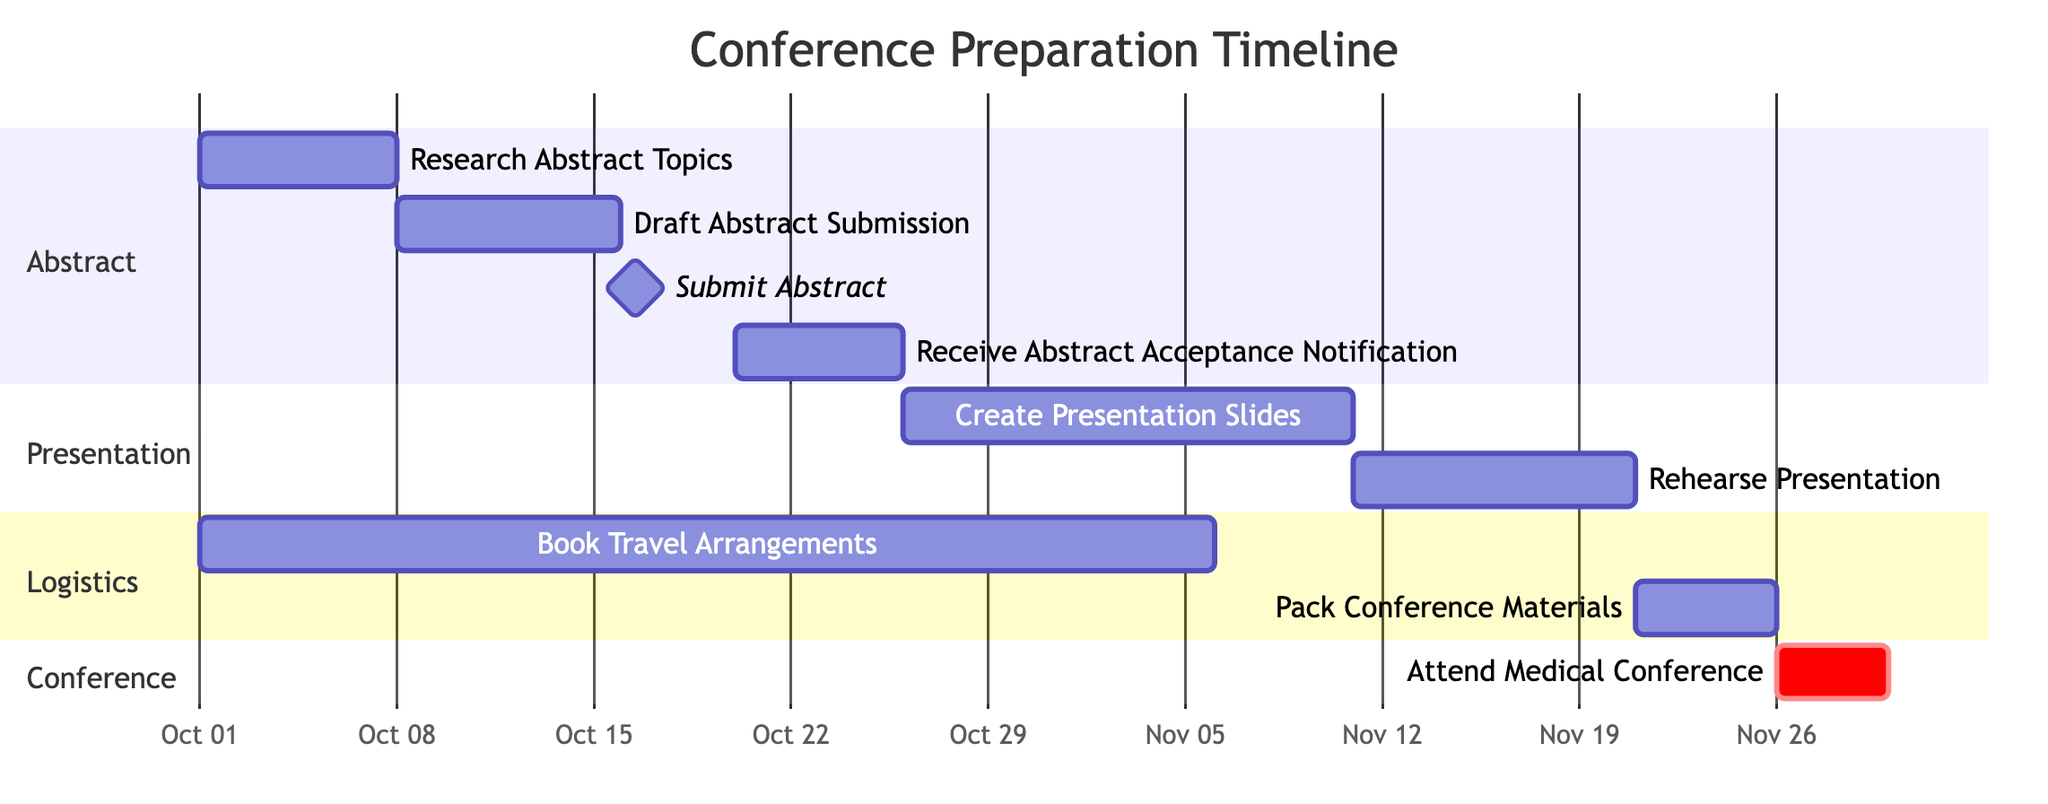What is the duration of the research phase for the abstract? The research phase for the abstract runs from October 1 to October 7. This is a total of 7 days.
Answer: 7 days What is the start date for creating presentation slides? According to the diagram, the task for creating presentation slides starts on October 26.
Answer: October 26 How many days are allocated for the "Rehearse Presentation" task? The "Rehearse Presentation" task starts on November 11 and lasts for 10 days until November 20. Therefore, it is allocated 10 days.
Answer: 10 days What task directly follows the "Draft Abstract Submission"? The task that directly follows "Draft Abstract Submission" is "Submit Abstract", which is a milestone task occurring immediately after the draft submission.
Answer: Submit Abstract Which task has the earliest start date among the logistics section? The earliest task in the logistics section is "Book Travel Arrangements", starting on October 1.
Answer: Book Travel Arrangements How many total tasks are there in the Gantt chart? By counting all the tasks in the chart, there are a total of 9 tasks shown in the diagram.
Answer: 9 tasks What is the end date for packing conference materials? The packing of conference materials ends on November 25, as specified in the timeline.
Answer: November 25 Which task is critical in the conference section of the Gantt chart? The critical task in the conference section is "Attend Medical Conference," which highlights its importance for the overall timeline.
Answer: Attend Medical Conference What is the last task that occurs before the medical conference? The last task before the medical conference is "Pack Conference Materials," which happens from November 21 to November 25.
Answer: Pack Conference Materials 